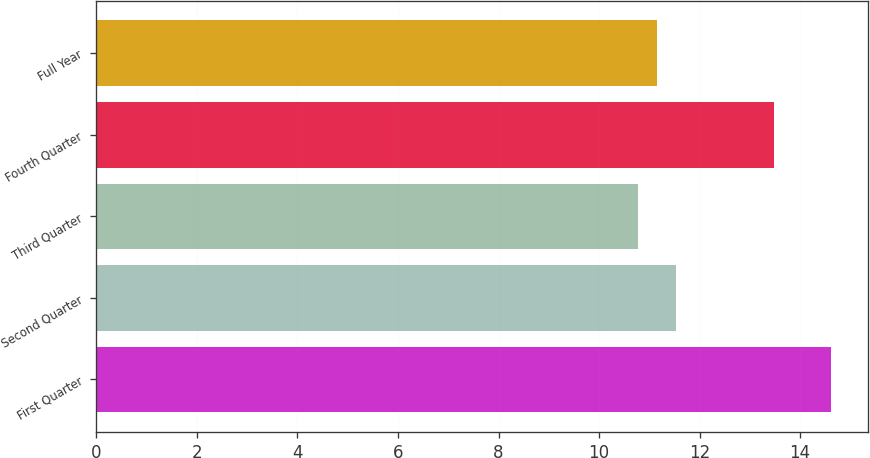<chart> <loc_0><loc_0><loc_500><loc_500><bar_chart><fcel>First Quarter<fcel>Second Quarter<fcel>Third Quarter<fcel>Fourth Quarter<fcel>Full Year<nl><fcel>14.61<fcel>11.53<fcel>10.77<fcel>13.48<fcel>11.15<nl></chart> 